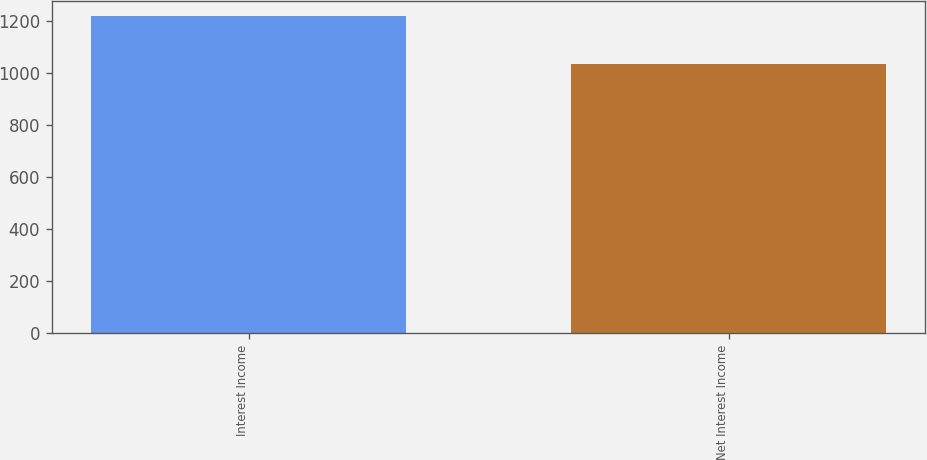<chart> <loc_0><loc_0><loc_500><loc_500><bar_chart><fcel>Interest Income<fcel>Net Interest Income<nl><fcel>1216.3<fcel>1034.9<nl></chart> 